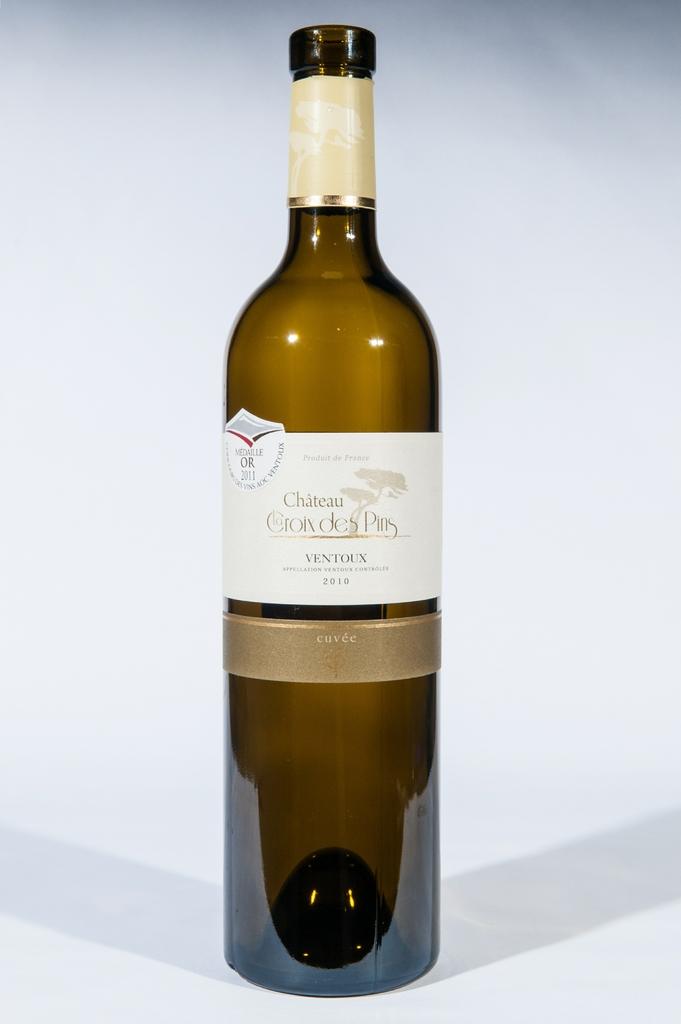What year was this bottled?
Give a very brief answer. 2010. 